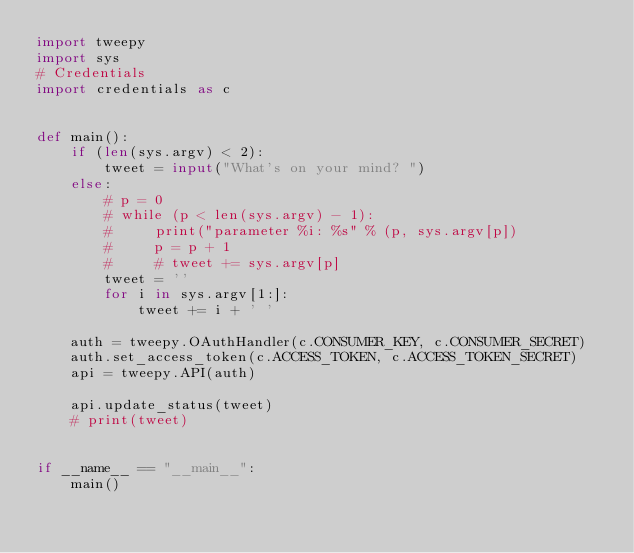Convert code to text. <code><loc_0><loc_0><loc_500><loc_500><_Python_>import tweepy
import sys
# Credentials
import credentials as c


def main():
    if (len(sys.argv) < 2):
        tweet = input("What's on your mind? ")
    else:
        # p = 0
        # while (p < len(sys.argv) - 1):
        #     print("parameter %i: %s" % (p, sys.argv[p])
        #     p = p + 1
        #     # tweet += sys.argv[p]
        tweet = ''
        for i in sys.argv[1:]:
            tweet += i + ' '

    auth = tweepy.OAuthHandler(c.CONSUMER_KEY, c.CONSUMER_SECRET)
    auth.set_access_token(c.ACCESS_TOKEN, c.ACCESS_TOKEN_SECRET)
    api = tweepy.API(auth)

    api.update_status(tweet)
    # print(tweet)


if __name__ == "__main__":
    main()
</code> 